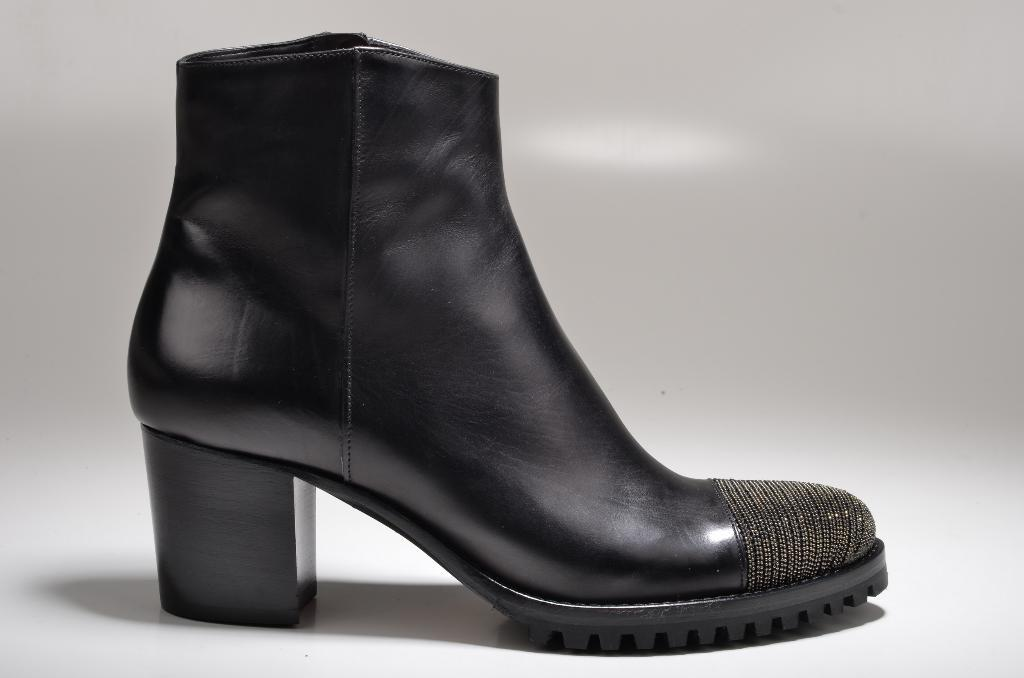What type of footwear is visible in the image? There is a black shoe in the image. What color is the background of the image? The background is white in color. How does the shoe generate steam in the image? The shoe does not generate steam in the image, as there is no indication of any steam or heat source. 